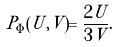<formula> <loc_0><loc_0><loc_500><loc_500>P _ { \Phi } ( U , V ) = \frac { 2 U } { 3 V } .</formula> 